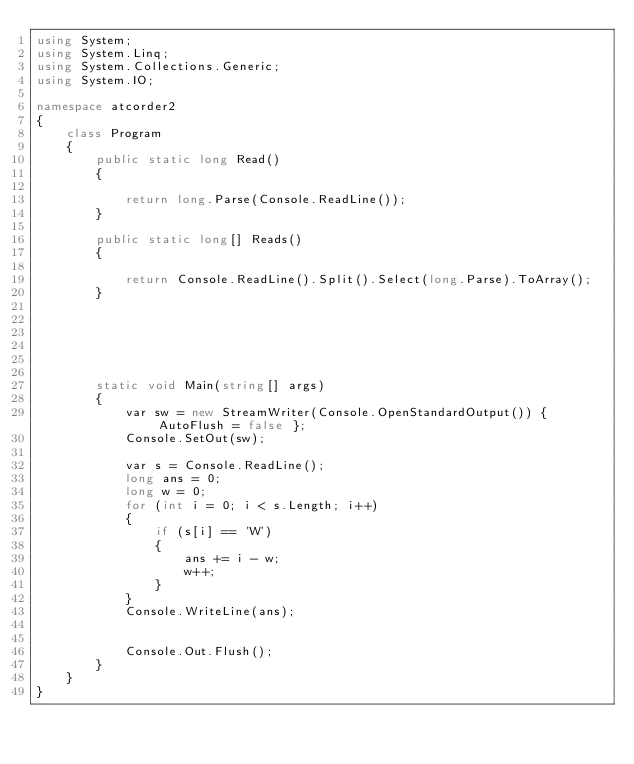Convert code to text. <code><loc_0><loc_0><loc_500><loc_500><_C#_>using System;
using System.Linq;
using System.Collections.Generic;
using System.IO;

namespace atcorder2
{
    class Program
    {
        public static long Read()
        {

            return long.Parse(Console.ReadLine());
        }

        public static long[] Reads()
        {

            return Console.ReadLine().Split().Select(long.Parse).ToArray();
        }

       




        static void Main(string[] args)
        {
            var sw = new StreamWriter(Console.OpenStandardOutput()) { AutoFlush = false };
            Console.SetOut(sw);

            var s = Console.ReadLine();
            long ans = 0;
            long w = 0;
            for (int i = 0; i < s.Length; i++)
            {
                if (s[i] == 'W')
                {
                    ans += i - w;
                    w++;
                }
            }
            Console.WriteLine(ans);


            Console.Out.Flush();
        }
    }
}


</code> 